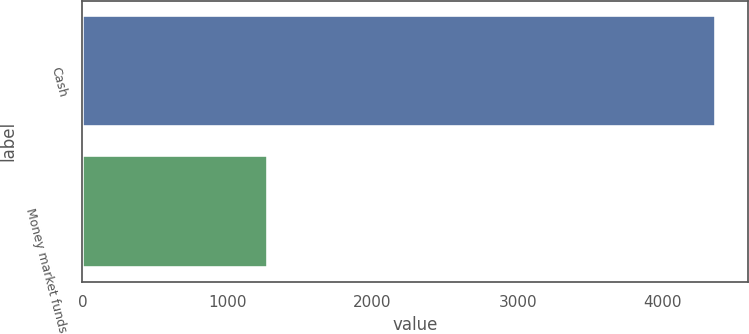Convert chart. <chart><loc_0><loc_0><loc_500><loc_500><bar_chart><fcel>Cash<fcel>Money market funds<nl><fcel>4367<fcel>1276<nl></chart> 